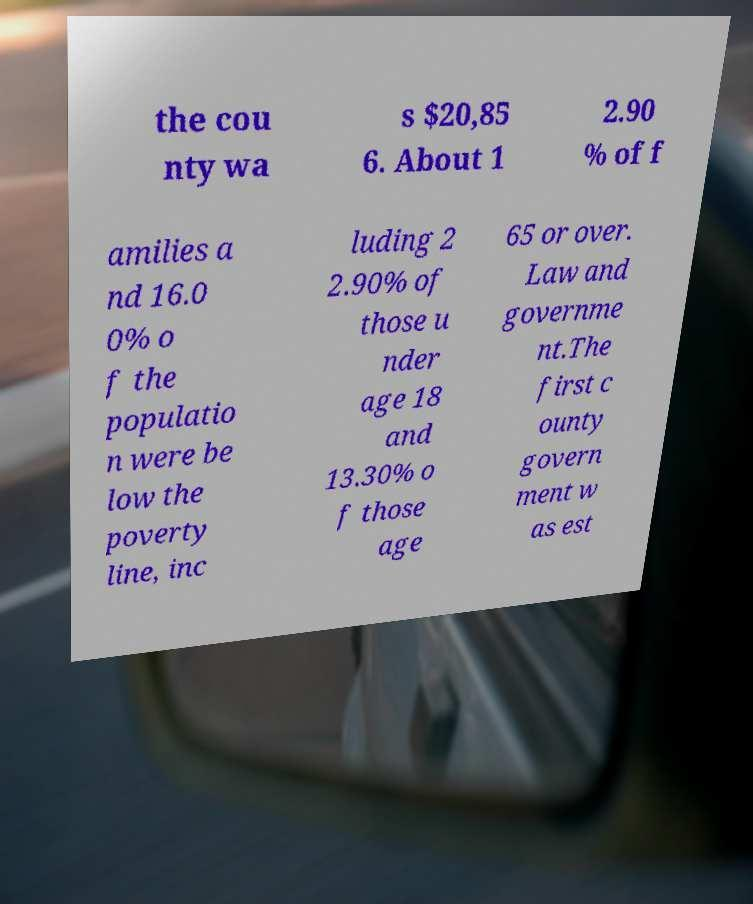Could you extract and type out the text from this image? the cou nty wa s $20,85 6. About 1 2.90 % of f amilies a nd 16.0 0% o f the populatio n were be low the poverty line, inc luding 2 2.90% of those u nder age 18 and 13.30% o f those age 65 or over. Law and governme nt.The first c ounty govern ment w as est 